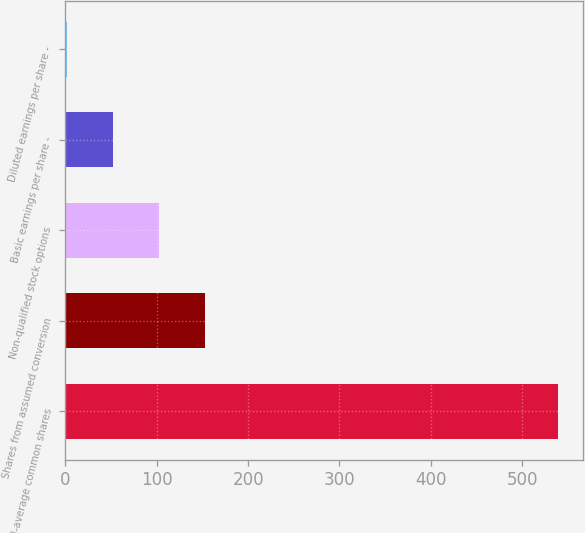Convert chart. <chart><loc_0><loc_0><loc_500><loc_500><bar_chart><fcel>Weighted-average common shares<fcel>Shares from assumed conversion<fcel>Non-qualified stock options<fcel>Basic earnings per share -<fcel>Diluted earnings per share -<nl><fcel>539.21<fcel>152.79<fcel>102.48<fcel>52.17<fcel>1.86<nl></chart> 